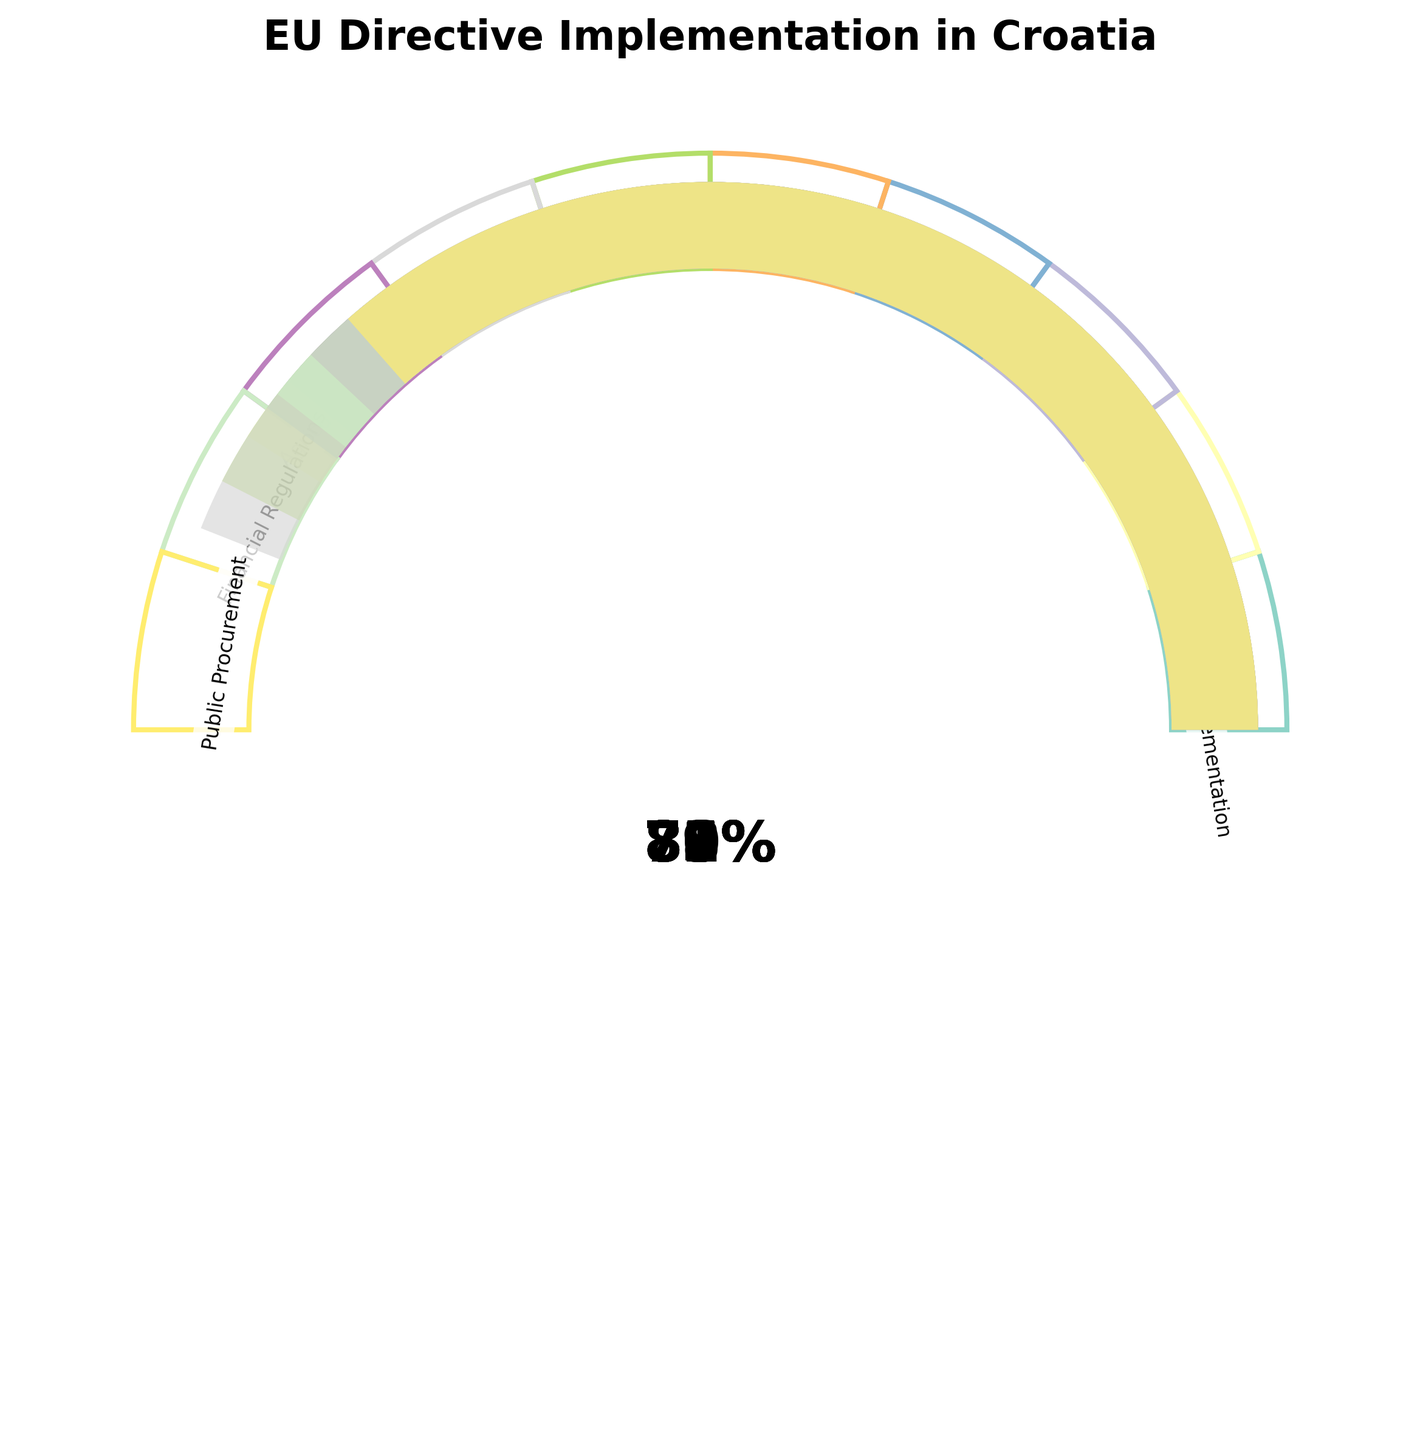What is the overall percentage of EU directive implementation in Croatia? The overall percentage can be found directly on the gauge labeled "Overall EU Directive Implementation."
Answer: 78% Which category has the highest level of implementation? To find the highest level, we compare the completion percentages in each category and identify the maximum value. Data Privacy has the highest value at 88%.
Answer: Data Privacy What is the level of implementation for Environmental Policies? Look for the gauge labeled "Environmental Policies," which shows the corresponding implementation level.
Answer: 82% How many categories have an implementation level higher than 80%? Count the categories with percentages greater than 80%. Environmental Policies (82%), Labor Laws (80%), Energy Efficiency (85%), and Data Privacy (88%) make a total of 4 categories.
Answer: 4 What is the difference in the level of implementation between Labor Laws and Consumer Protection? Subtract the percentage for Consumer Protection from that of Labor Laws: 80% - 75% = 5%.
Answer: 5% Which category has the lowest level of implementation? Among the given values, the category with the smallest percentage is Digital Single Market with 71%.
Answer: Digital Single Market How does the implementation of Agricultural Standards compare to Financial Regulations? Compare the percentages for Agricultural Standards and Financial Regulations: 76% for Agricultural Standards and 79% for Financial Regulations. Since 76% < 79%, Agricultural Standards is lower.
Answer: Financial Regulations higher What is the average level of implementation across all categories? Add all the percentages together and then divide by the number of categories: (78 + 82 + 75 + 80 + 71 + 85 + 88 + 76 + 79 + 73) / 10 = 78.7%.
Answer: 78.7% Is the implementation level for Public Procurement more than or less than 75%? Look at the percentage for Public Procurement in the chart, which is 73%, and compare it to 75%. 73% is less than 75%.
Answer: Less than What is the implementation rate difference between the highest and lowest categories? The highest category is Data Privacy at 88%, and the lowest is Digital Single Market at 71%. The difference is 88% - 71% = 17%.
Answer: 17% 